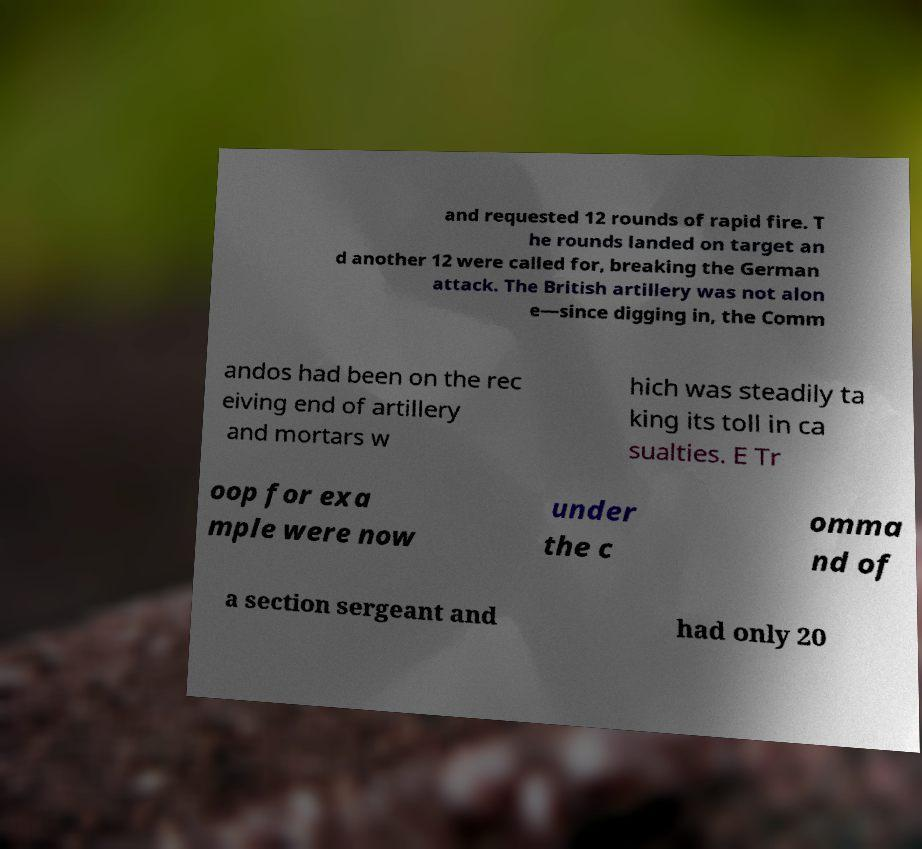Could you extract and type out the text from this image? and requested 12 rounds of rapid fire. T he rounds landed on target an d another 12 were called for, breaking the German attack. The British artillery was not alon e—since digging in, the Comm andos had been on the rec eiving end of artillery and mortars w hich was steadily ta king its toll in ca sualties. E Tr oop for exa mple were now under the c omma nd of a section sergeant and had only 20 